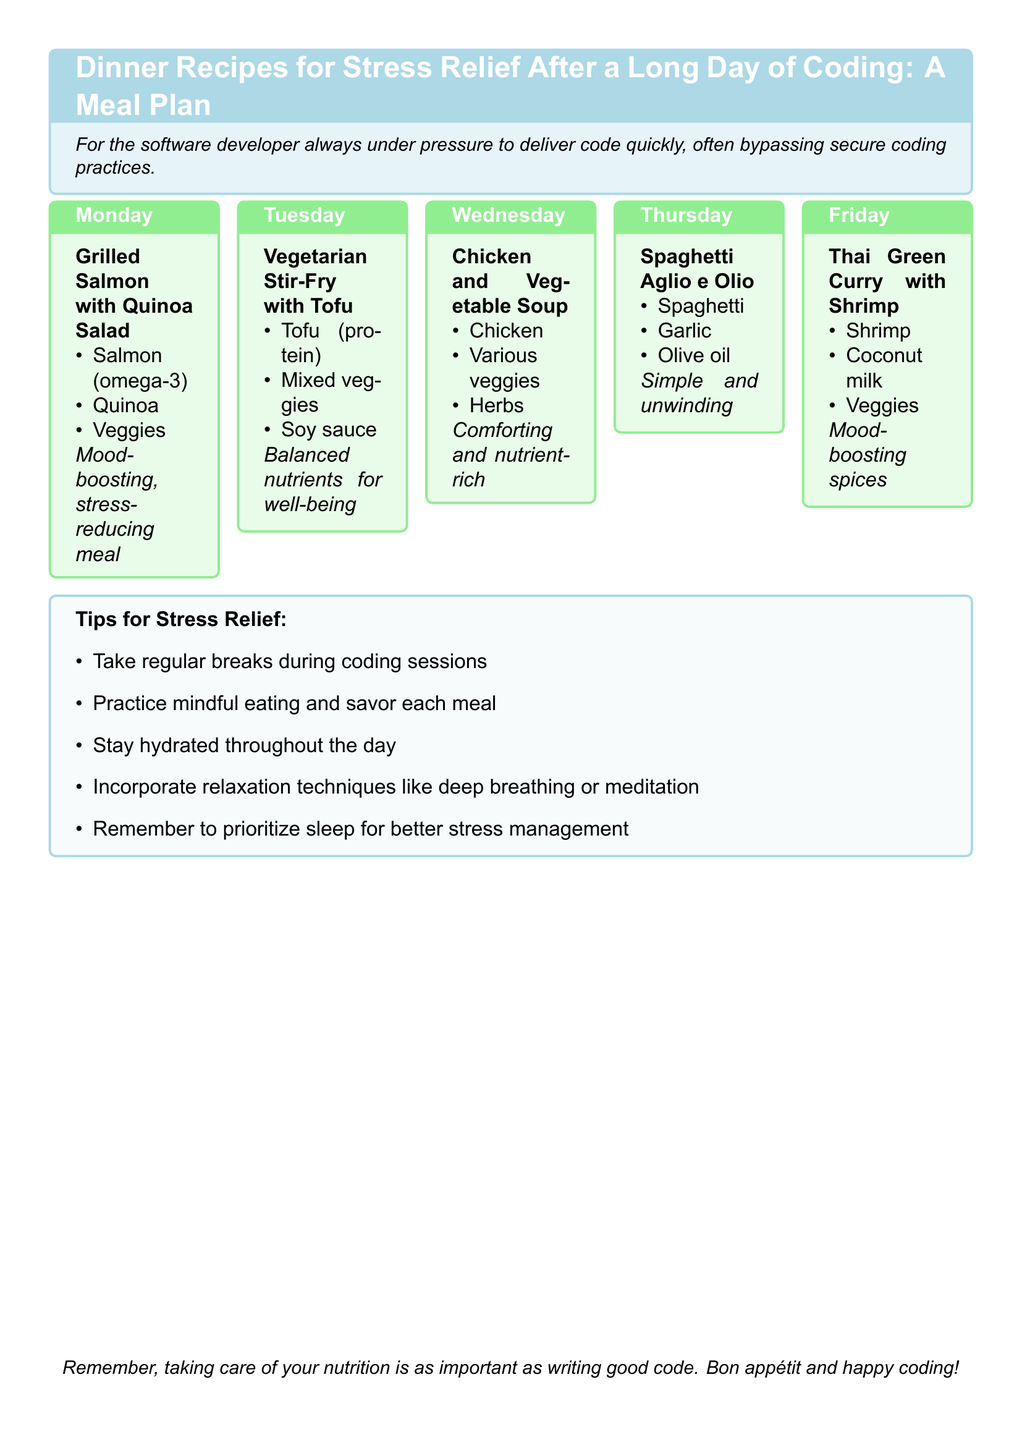What is the meal for Monday? The meal listed for Monday in the meal plan is Grilled Salmon with Quinoa Salad.
Answer: Grilled Salmon with Quinoa Salad What type of cuisine is offered on Friday? The meal listed for Friday is Thai Green Curry with Shrimp, which is a type of Thai cuisine.
Answer: Thai What is a key ingredient in the Tuesday meal? The dish for Tuesday is Vegetarian Stir-Fry with Tofu, and one key ingredient is Tofu.
Answer: Tofu How many meals are there in the meal plan? The meal plan includes a total of five meals, one for each day from Monday to Friday.
Answer: Five What is a stress relief tip mentioned in the document? One of the tips for stress relief provided in the document is to take regular breaks during coding sessions.
Answer: Take regular breaks Which day features a simple meal? The meal on Thursday is Spaghetti Aglio e Olio, described as simple.
Answer: Thursday What mood-boosting ingredient is found in the Friday meal? The Thai Green Curry with Shrimp includes mood-boosting spices as a description, but specific ingredients are not detailed.
Answer: Spices What type of protein is in the Wednesday meal? The meal for Wednesday is Chicken and Vegetable Soup, where Chicken is a type of protein.
Answer: Chicken 